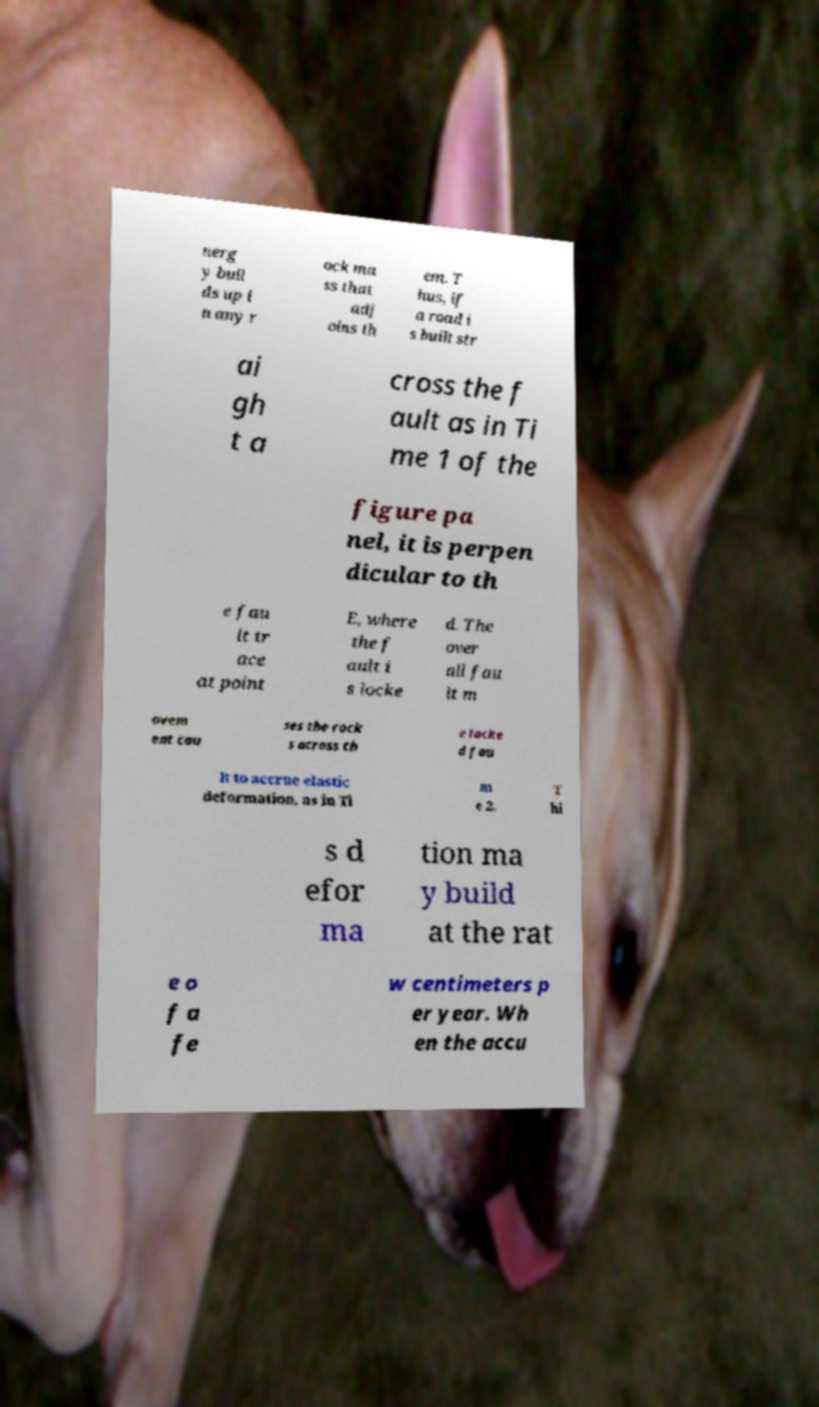There's text embedded in this image that I need extracted. Can you transcribe it verbatim? nerg y buil ds up i n any r ock ma ss that adj oins th em. T hus, if a road i s built str ai gh t a cross the f ault as in Ti me 1 of the figure pa nel, it is perpen dicular to th e fau lt tr ace at point E, where the f ault i s locke d. The over all fau lt m ovem ent cau ses the rock s across th e locke d fau lt to accrue elastic deformation, as in Ti m e 2. T hi s d efor ma tion ma y build at the rat e o f a fe w centimeters p er year. Wh en the accu 